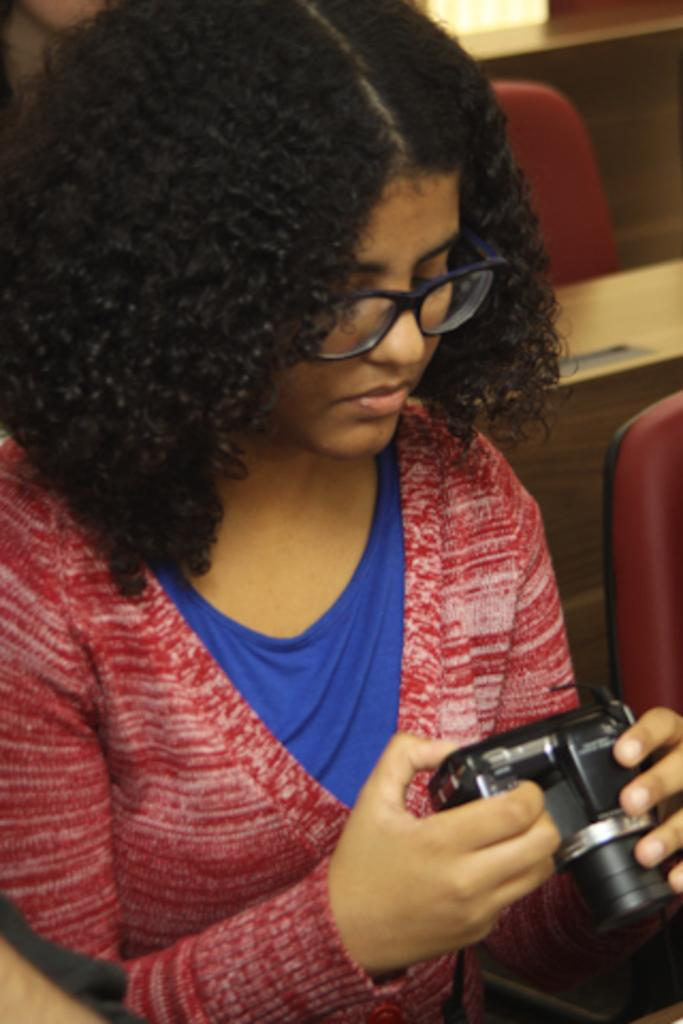Who is the main subject in the image? There is a girl in the image. What is the girl wearing on her upper body? The girl is wearing a red jacket and a blue t-shirt. What is the girl holding in her hands? The girl is holding a camera in her hands. Can you describe the girl's hair? The girl has curly hair. What accessory is the girl wearing on her face? The girl is wearing specs. What type of harbor can be seen in the background of the image? There is no harbor visible in the image; it features a girl holding a camera. What discovery was made by the girl in the image? There is no mention of a discovery in the image; it simply shows a girl holding a camera. 